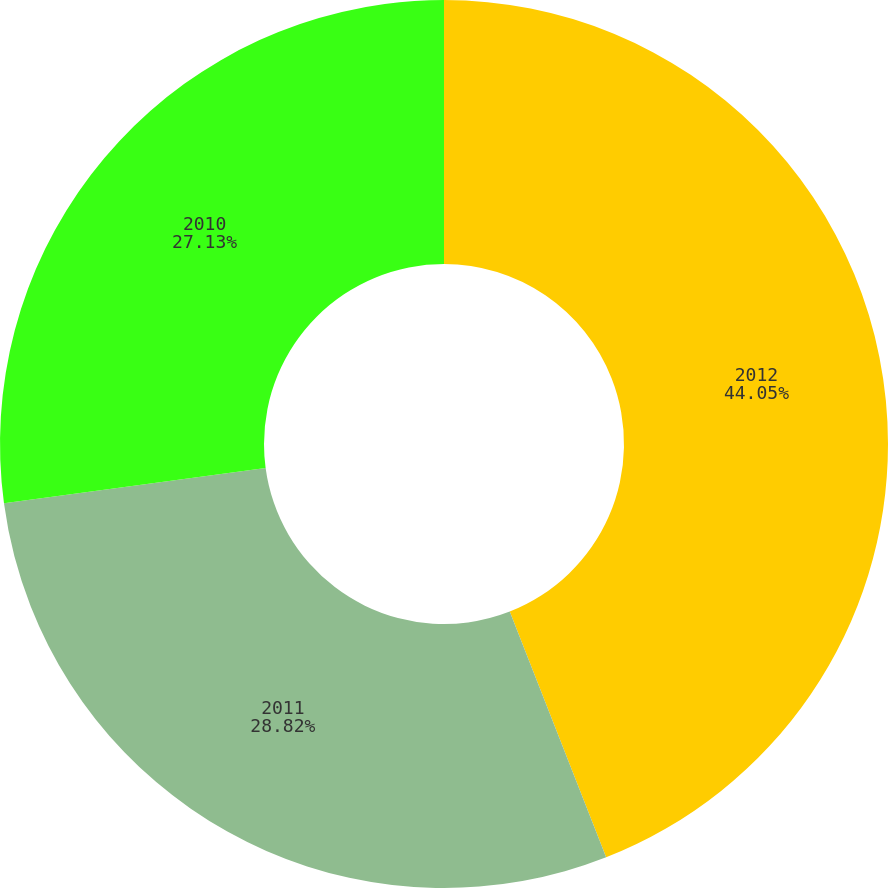<chart> <loc_0><loc_0><loc_500><loc_500><pie_chart><fcel>2012<fcel>2011<fcel>2010<nl><fcel>44.05%<fcel>28.82%<fcel>27.13%<nl></chart> 